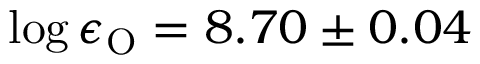Convert formula to latex. <formula><loc_0><loc_0><loc_500><loc_500>\log \epsilon _ { O } = 8 . 7 0 \pm 0 . 0 4</formula> 